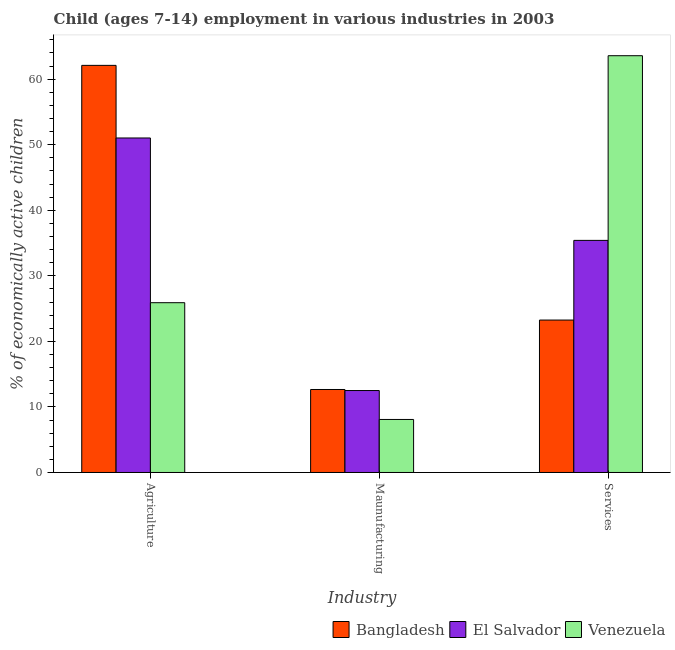How many bars are there on the 3rd tick from the left?
Ensure brevity in your answer.  3. How many bars are there on the 2nd tick from the right?
Your answer should be compact. 3. What is the label of the 1st group of bars from the left?
Your answer should be very brief. Agriculture. What is the percentage of economically active children in services in El Salvador?
Offer a very short reply. 35.4. Across all countries, what is the maximum percentage of economically active children in agriculture?
Ensure brevity in your answer.  62.1. Across all countries, what is the minimum percentage of economically active children in agriculture?
Give a very brief answer. 25.9. In which country was the percentage of economically active children in manufacturing maximum?
Offer a terse response. Bangladesh. In which country was the percentage of economically active children in manufacturing minimum?
Keep it short and to the point. Venezuela. What is the total percentage of economically active children in services in the graph?
Your response must be concise. 122.23. What is the difference between the percentage of economically active children in manufacturing in Venezuela and that in Bangladesh?
Your response must be concise. -4.57. What is the difference between the percentage of economically active children in services in Venezuela and the percentage of economically active children in agriculture in Bangladesh?
Offer a very short reply. 1.47. What is the average percentage of economically active children in manufacturing per country?
Offer a very short reply. 11.08. What is the difference between the percentage of economically active children in manufacturing and percentage of economically active children in services in El Salvador?
Offer a very short reply. -22.9. In how many countries, is the percentage of economically active children in manufacturing greater than 8 %?
Make the answer very short. 3. What is the ratio of the percentage of economically active children in manufacturing in El Salvador to that in Bangladesh?
Your answer should be very brief. 0.99. What is the difference between the highest and the second highest percentage of economically active children in agriculture?
Your response must be concise. 11.07. What is the difference between the highest and the lowest percentage of economically active children in agriculture?
Keep it short and to the point. 36.2. In how many countries, is the percentage of economically active children in services greater than the average percentage of economically active children in services taken over all countries?
Make the answer very short. 1. Is the sum of the percentage of economically active children in agriculture in El Salvador and Venezuela greater than the maximum percentage of economically active children in manufacturing across all countries?
Give a very brief answer. Yes. What does the 3rd bar from the left in Services represents?
Make the answer very short. Venezuela. What does the 1st bar from the right in Agriculture represents?
Make the answer very short. Venezuela. Is it the case that in every country, the sum of the percentage of economically active children in agriculture and percentage of economically active children in manufacturing is greater than the percentage of economically active children in services?
Offer a terse response. No. How many countries are there in the graph?
Make the answer very short. 3. Are the values on the major ticks of Y-axis written in scientific E-notation?
Make the answer very short. No. Does the graph contain any zero values?
Ensure brevity in your answer.  No. Does the graph contain grids?
Your answer should be compact. No. Where does the legend appear in the graph?
Keep it short and to the point. Bottom right. How many legend labels are there?
Give a very brief answer. 3. What is the title of the graph?
Ensure brevity in your answer.  Child (ages 7-14) employment in various industries in 2003. What is the label or title of the X-axis?
Offer a very short reply. Industry. What is the label or title of the Y-axis?
Give a very brief answer. % of economically active children. What is the % of economically active children of Bangladesh in Agriculture?
Provide a succinct answer. 62.1. What is the % of economically active children of El Salvador in Agriculture?
Provide a succinct answer. 51.03. What is the % of economically active children in Venezuela in Agriculture?
Give a very brief answer. 25.9. What is the % of economically active children in Bangladesh in Maunufacturing?
Your response must be concise. 12.66. What is the % of economically active children in El Salvador in Maunufacturing?
Offer a terse response. 12.5. What is the % of economically active children of Venezuela in Maunufacturing?
Your answer should be compact. 8.09. What is the % of economically active children in Bangladesh in Services?
Make the answer very short. 23.25. What is the % of economically active children in El Salvador in Services?
Offer a very short reply. 35.4. What is the % of economically active children of Venezuela in Services?
Offer a very short reply. 63.57. Across all Industry, what is the maximum % of economically active children in Bangladesh?
Keep it short and to the point. 62.1. Across all Industry, what is the maximum % of economically active children in El Salvador?
Make the answer very short. 51.03. Across all Industry, what is the maximum % of economically active children in Venezuela?
Provide a short and direct response. 63.57. Across all Industry, what is the minimum % of economically active children in Bangladesh?
Your answer should be compact. 12.66. Across all Industry, what is the minimum % of economically active children of El Salvador?
Keep it short and to the point. 12.5. Across all Industry, what is the minimum % of economically active children in Venezuela?
Your answer should be very brief. 8.09. What is the total % of economically active children of Bangladesh in the graph?
Offer a very short reply. 98.01. What is the total % of economically active children in El Salvador in the graph?
Keep it short and to the point. 98.93. What is the total % of economically active children of Venezuela in the graph?
Make the answer very short. 97.56. What is the difference between the % of economically active children of Bangladesh in Agriculture and that in Maunufacturing?
Make the answer very short. 49.44. What is the difference between the % of economically active children in El Salvador in Agriculture and that in Maunufacturing?
Provide a short and direct response. 38.53. What is the difference between the % of economically active children of Venezuela in Agriculture and that in Maunufacturing?
Ensure brevity in your answer.  17.81. What is the difference between the % of economically active children in Bangladesh in Agriculture and that in Services?
Keep it short and to the point. 38.85. What is the difference between the % of economically active children of El Salvador in Agriculture and that in Services?
Provide a short and direct response. 15.62. What is the difference between the % of economically active children of Venezuela in Agriculture and that in Services?
Provide a short and direct response. -37.67. What is the difference between the % of economically active children of Bangladesh in Maunufacturing and that in Services?
Give a very brief answer. -10.59. What is the difference between the % of economically active children of El Salvador in Maunufacturing and that in Services?
Your answer should be very brief. -22.9. What is the difference between the % of economically active children of Venezuela in Maunufacturing and that in Services?
Ensure brevity in your answer.  -55.49. What is the difference between the % of economically active children of Bangladesh in Agriculture and the % of economically active children of El Salvador in Maunufacturing?
Offer a terse response. 49.6. What is the difference between the % of economically active children of Bangladesh in Agriculture and the % of economically active children of Venezuela in Maunufacturing?
Your answer should be compact. 54.01. What is the difference between the % of economically active children in El Salvador in Agriculture and the % of economically active children in Venezuela in Maunufacturing?
Your answer should be compact. 42.94. What is the difference between the % of economically active children in Bangladesh in Agriculture and the % of economically active children in El Salvador in Services?
Make the answer very short. 26.7. What is the difference between the % of economically active children in Bangladesh in Agriculture and the % of economically active children in Venezuela in Services?
Your answer should be compact. -1.47. What is the difference between the % of economically active children in El Salvador in Agriculture and the % of economically active children in Venezuela in Services?
Provide a succinct answer. -12.55. What is the difference between the % of economically active children in Bangladesh in Maunufacturing and the % of economically active children in El Salvador in Services?
Offer a terse response. -22.74. What is the difference between the % of economically active children in Bangladesh in Maunufacturing and the % of economically active children in Venezuela in Services?
Your answer should be very brief. -50.91. What is the difference between the % of economically active children in El Salvador in Maunufacturing and the % of economically active children in Venezuela in Services?
Make the answer very short. -51.07. What is the average % of economically active children of Bangladesh per Industry?
Provide a short and direct response. 32.67. What is the average % of economically active children of El Salvador per Industry?
Give a very brief answer. 32.98. What is the average % of economically active children of Venezuela per Industry?
Make the answer very short. 32.52. What is the difference between the % of economically active children of Bangladesh and % of economically active children of El Salvador in Agriculture?
Your response must be concise. 11.07. What is the difference between the % of economically active children of Bangladesh and % of economically active children of Venezuela in Agriculture?
Your response must be concise. 36.2. What is the difference between the % of economically active children in El Salvador and % of economically active children in Venezuela in Agriculture?
Make the answer very short. 25.13. What is the difference between the % of economically active children of Bangladesh and % of economically active children of El Salvador in Maunufacturing?
Give a very brief answer. 0.16. What is the difference between the % of economically active children in Bangladesh and % of economically active children in Venezuela in Maunufacturing?
Ensure brevity in your answer.  4.57. What is the difference between the % of economically active children of El Salvador and % of economically active children of Venezuela in Maunufacturing?
Make the answer very short. 4.41. What is the difference between the % of economically active children of Bangladesh and % of economically active children of El Salvador in Services?
Ensure brevity in your answer.  -12.15. What is the difference between the % of economically active children in Bangladesh and % of economically active children in Venezuela in Services?
Offer a terse response. -40.32. What is the difference between the % of economically active children in El Salvador and % of economically active children in Venezuela in Services?
Provide a succinct answer. -28.17. What is the ratio of the % of economically active children of Bangladesh in Agriculture to that in Maunufacturing?
Provide a succinct answer. 4.91. What is the ratio of the % of economically active children in El Salvador in Agriculture to that in Maunufacturing?
Your answer should be very brief. 4.08. What is the ratio of the % of economically active children in Venezuela in Agriculture to that in Maunufacturing?
Keep it short and to the point. 3.2. What is the ratio of the % of economically active children in Bangladesh in Agriculture to that in Services?
Your response must be concise. 2.67. What is the ratio of the % of economically active children of El Salvador in Agriculture to that in Services?
Your answer should be compact. 1.44. What is the ratio of the % of economically active children of Venezuela in Agriculture to that in Services?
Make the answer very short. 0.41. What is the ratio of the % of economically active children in Bangladesh in Maunufacturing to that in Services?
Your answer should be very brief. 0.54. What is the ratio of the % of economically active children in El Salvador in Maunufacturing to that in Services?
Your answer should be compact. 0.35. What is the ratio of the % of economically active children of Venezuela in Maunufacturing to that in Services?
Give a very brief answer. 0.13. What is the difference between the highest and the second highest % of economically active children of Bangladesh?
Ensure brevity in your answer.  38.85. What is the difference between the highest and the second highest % of economically active children in El Salvador?
Provide a short and direct response. 15.62. What is the difference between the highest and the second highest % of economically active children in Venezuela?
Make the answer very short. 37.67. What is the difference between the highest and the lowest % of economically active children of Bangladesh?
Offer a terse response. 49.44. What is the difference between the highest and the lowest % of economically active children in El Salvador?
Keep it short and to the point. 38.53. What is the difference between the highest and the lowest % of economically active children in Venezuela?
Give a very brief answer. 55.49. 